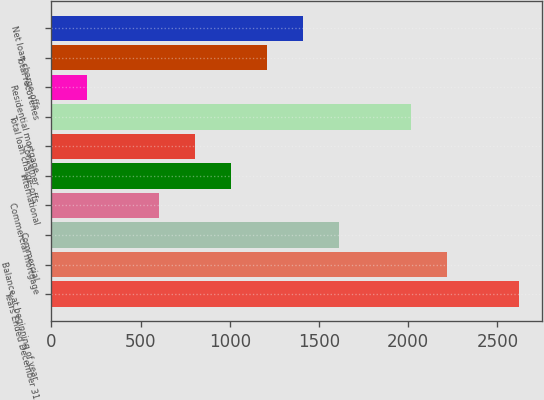Convert chart. <chart><loc_0><loc_0><loc_500><loc_500><bar_chart><fcel>Years Ended December 31<fcel>Balance at beginning of year<fcel>Commercial<fcel>Commercial mortgage<fcel>International<fcel>Consumer<fcel>Total loan charge-offs<fcel>Residential mortgage<fcel>Total recoveries<fcel>Net loan charge-offs<nl><fcel>2619.45<fcel>2216.49<fcel>1612.05<fcel>604.65<fcel>1007.61<fcel>806.13<fcel>2015.01<fcel>201.69<fcel>1209.09<fcel>1410.57<nl></chart> 